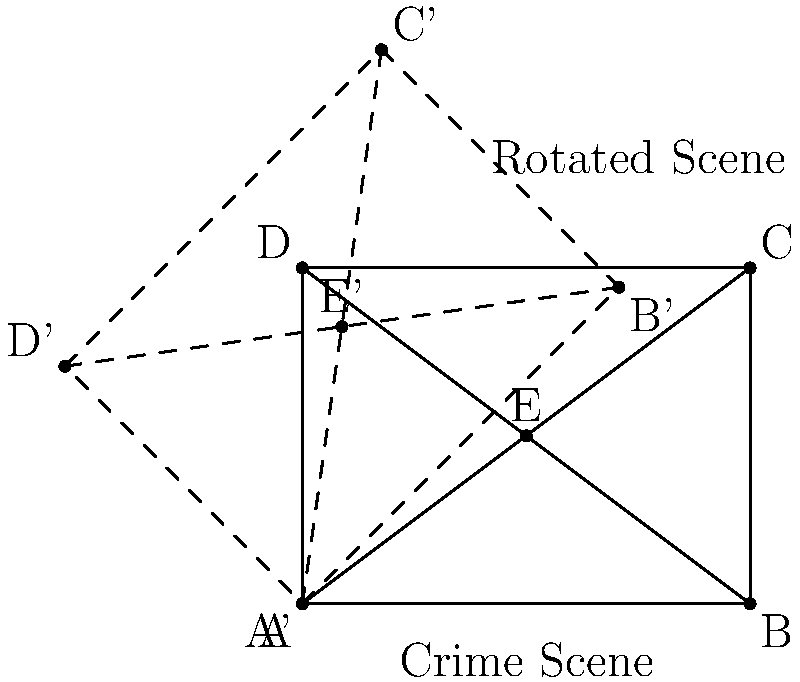In your latest crime novel, a witness claims to have seen the crime scene from a different angle than the original police diagram. To verify their statement, you need to rotate the crime scene diagram by 45° clockwise. If point E represents the location of a crucial piece of evidence in the original diagram, what are the coordinates of E' (the rotated position of E) after the rotation? To find the coordinates of E' after a 45° clockwise rotation, we can follow these steps:

1. Identify the original coordinates of E: (2, 1.5)

2. Use the rotation formula for a point (x, y) rotated by an angle θ:
   x' = x cos θ - y sin θ
   y' = x sin θ + y cos θ

3. For a 45° clockwise rotation, θ = -45° (negative because it's clockwise)
   cos(-45°) = $\frac{\sqrt{2}}{2}$
   sin(-45°) = $-\frac{\sqrt{2}}{2}$

4. Substitute the values into the rotation formula:
   x' = 2 * $\frac{\sqrt{2}}{2}$ - 1.5 * $(-\frac{\sqrt{2}}{2})$ = $\sqrt{2} + \frac{3\sqrt{2}}{4}$ = $\frac{7\sqrt{2}}{4}$
   y' = 2 * $(-\frac{\sqrt{2}}{2})$ + 1.5 * $\frac{\sqrt{2}}{2}$ = $-\sqrt{2} + \frac{3\sqrt{2}}{4}$ = $-\frac{\sqrt{2}}{4}$

5. Simplify the coordinates:
   E' = ($\frac{7\sqrt{2}}{4}$, $-\frac{\sqrt{2}}{4}$)
Answer: ($\frac{7\sqrt{2}}{4}$, $-\frac{\sqrt{2}}{4}$) 